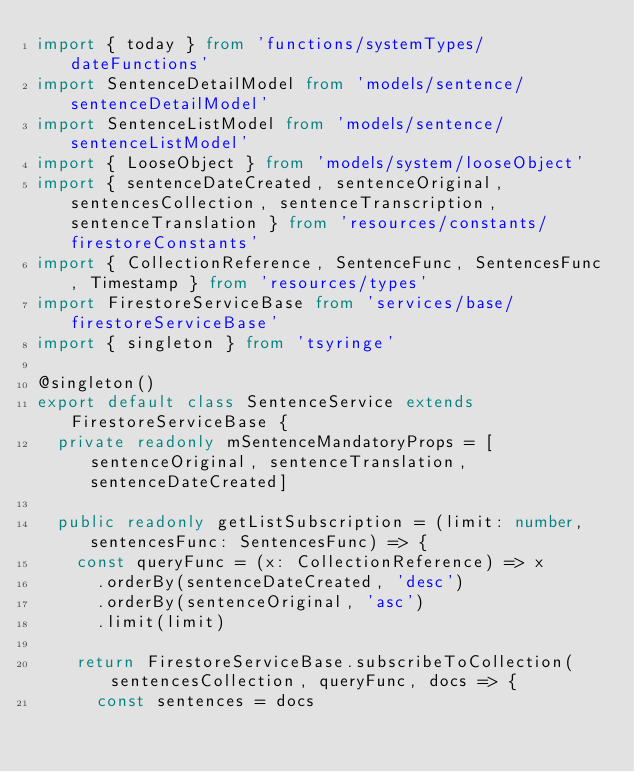<code> <loc_0><loc_0><loc_500><loc_500><_TypeScript_>import { today } from 'functions/systemTypes/dateFunctions'
import SentenceDetailModel from 'models/sentence/sentenceDetailModel'
import SentenceListModel from 'models/sentence/sentenceListModel'
import { LooseObject } from 'models/system/looseObject'
import { sentenceDateCreated, sentenceOriginal, sentencesCollection, sentenceTranscription, sentenceTranslation } from 'resources/constants/firestoreConstants'
import { CollectionReference, SentenceFunc, SentencesFunc, Timestamp } from 'resources/types'
import FirestoreServiceBase from 'services/base/firestoreServiceBase'
import { singleton } from 'tsyringe'

@singleton()
export default class SentenceService extends FirestoreServiceBase {
	private readonly mSentenceMandatoryProps = [sentenceOriginal, sentenceTranslation, sentenceDateCreated]

	public readonly getListSubscription = (limit: number, sentencesFunc: SentencesFunc) => {
		const queryFunc = (x: CollectionReference) => x
			.orderBy(sentenceDateCreated, 'desc')
			.orderBy(sentenceOriginal, 'asc')
			.limit(limit)

		return FirestoreServiceBase.subscribeToCollection(sentencesCollection, queryFunc, docs => {
			const sentences = docs</code> 